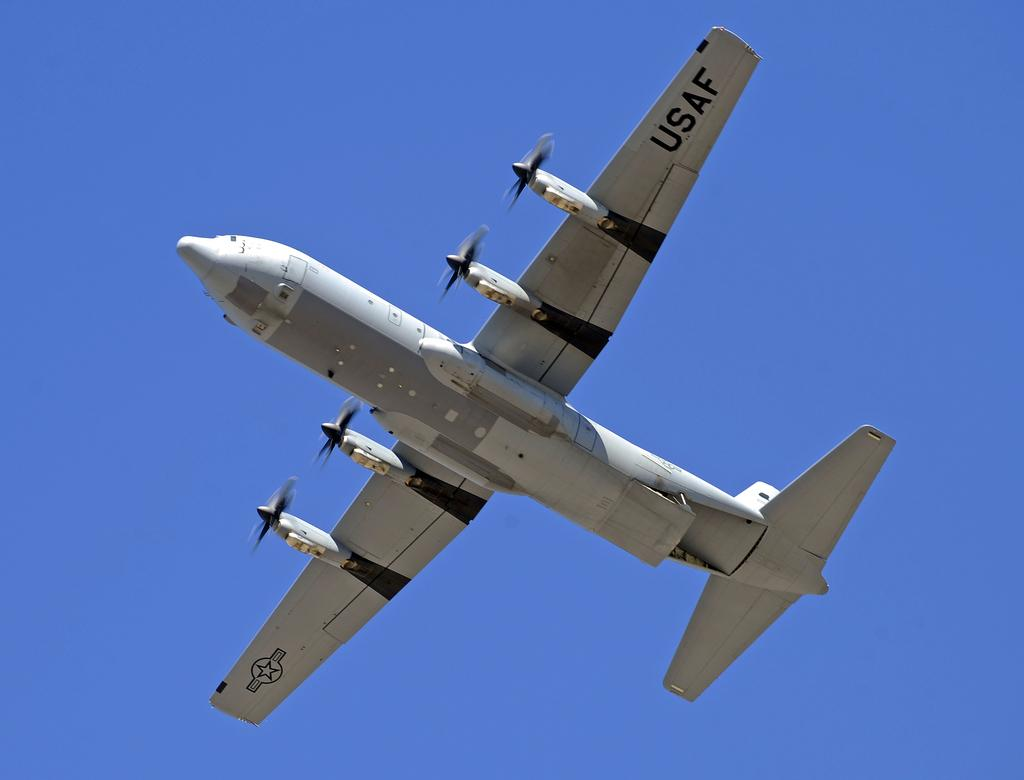<image>
Give a short and clear explanation of the subsequent image. the USAF plane is flying through the clear blue sky 